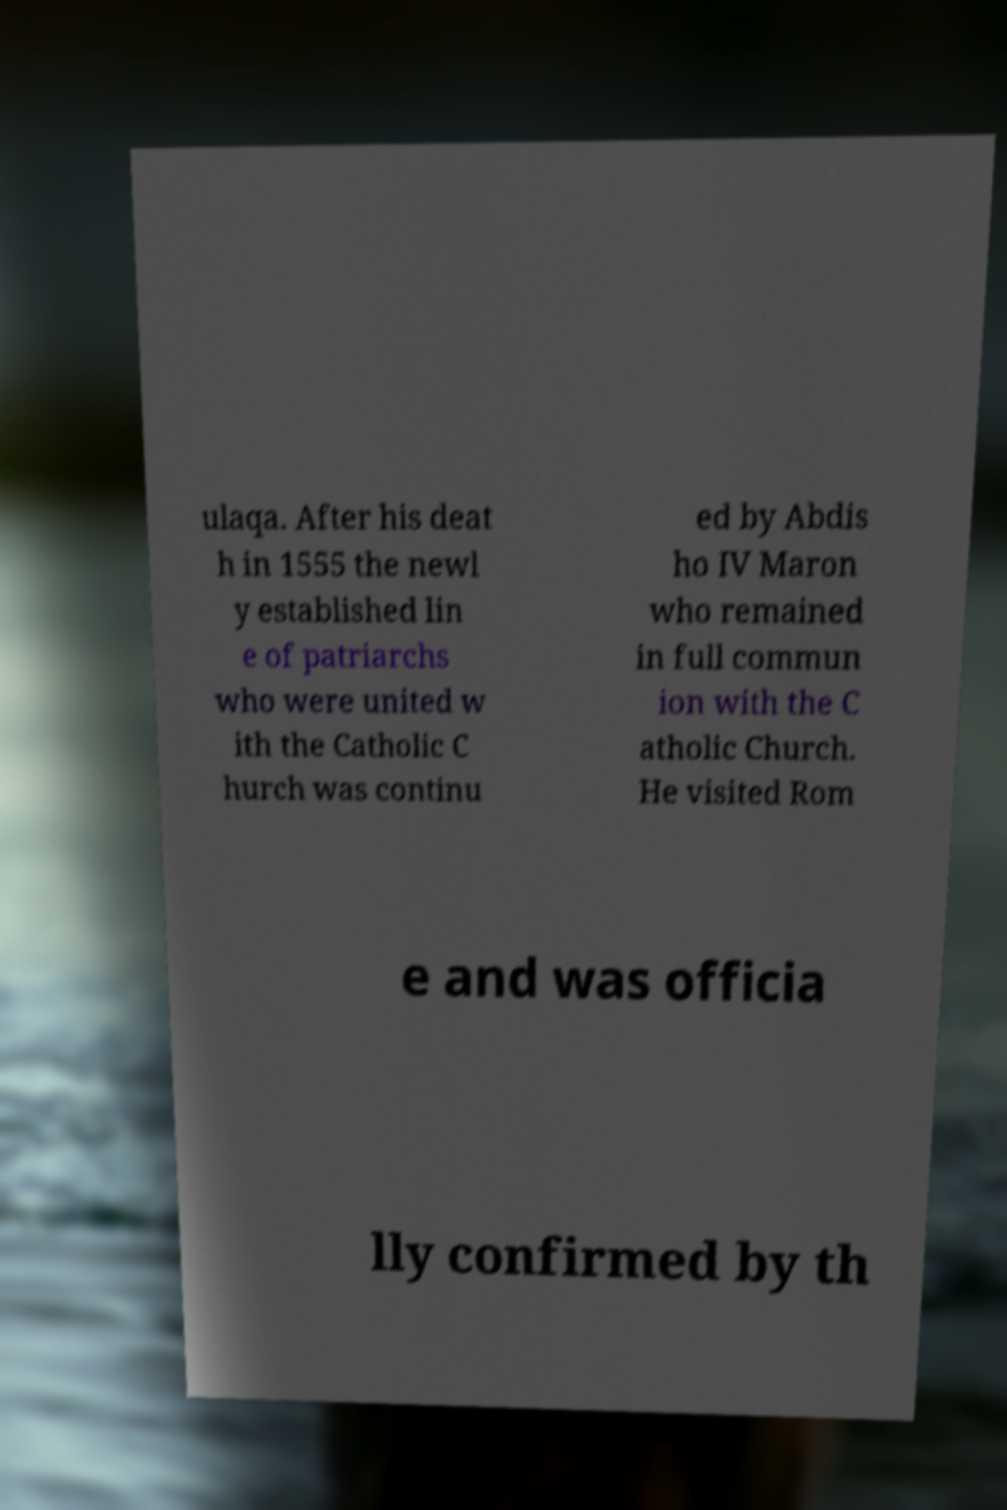I need the written content from this picture converted into text. Can you do that? ulaqa. After his deat h in 1555 the newl y established lin e of patriarchs who were united w ith the Catholic C hurch was continu ed by Abdis ho IV Maron who remained in full commun ion with the C atholic Church. He visited Rom e and was officia lly confirmed by th 